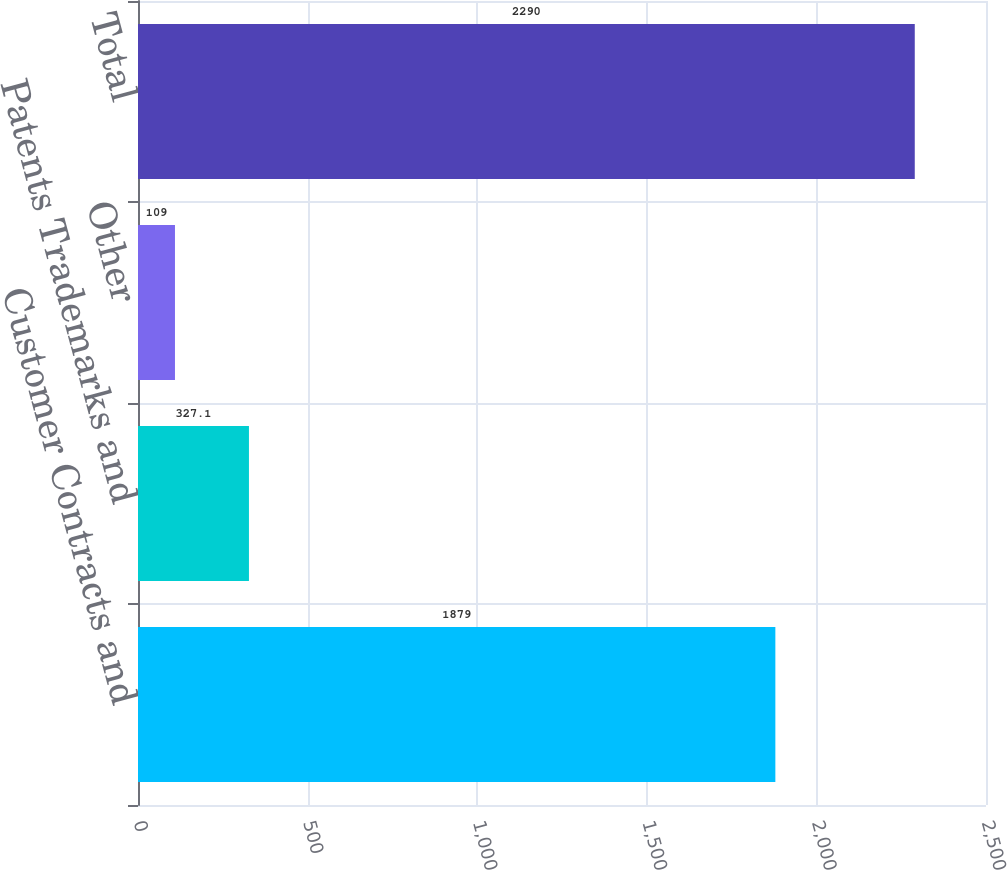<chart> <loc_0><loc_0><loc_500><loc_500><bar_chart><fcel>Customer Contracts and<fcel>Patents Trademarks and<fcel>Other<fcel>Total<nl><fcel>1879<fcel>327.1<fcel>109<fcel>2290<nl></chart> 